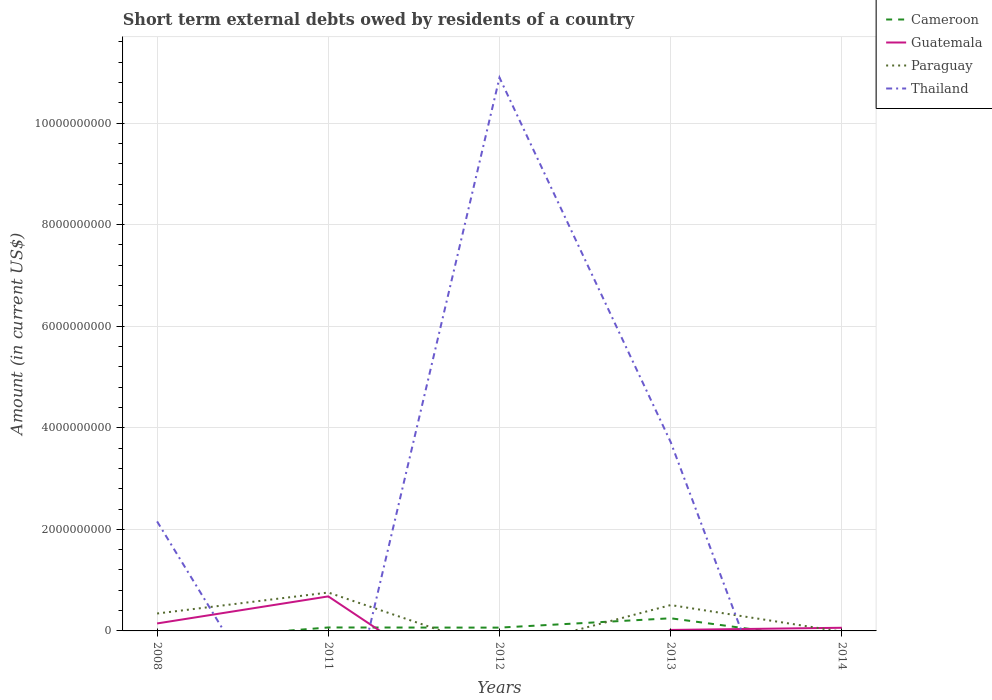Does the line corresponding to Guatemala intersect with the line corresponding to Cameroon?
Provide a succinct answer. Yes. Is the number of lines equal to the number of legend labels?
Give a very brief answer. No. What is the total amount of short-term external debts owed by residents in Cameroon in the graph?
Ensure brevity in your answer.  -1.84e+08. What is the difference between the highest and the second highest amount of short-term external debts owed by residents in Thailand?
Provide a short and direct response. 1.09e+1. What is the difference between the highest and the lowest amount of short-term external debts owed by residents in Paraguay?
Your response must be concise. 3. How many lines are there?
Offer a very short reply. 4. Are the values on the major ticks of Y-axis written in scientific E-notation?
Provide a short and direct response. No. Where does the legend appear in the graph?
Offer a very short reply. Top right. How many legend labels are there?
Provide a succinct answer. 4. What is the title of the graph?
Your answer should be very brief. Short term external debts owed by residents of a country. What is the label or title of the Y-axis?
Offer a terse response. Amount (in current US$). What is the Amount (in current US$) of Cameroon in 2008?
Ensure brevity in your answer.  0. What is the Amount (in current US$) in Guatemala in 2008?
Ensure brevity in your answer.  1.47e+08. What is the Amount (in current US$) of Paraguay in 2008?
Ensure brevity in your answer.  3.43e+08. What is the Amount (in current US$) of Thailand in 2008?
Offer a very short reply. 2.16e+09. What is the Amount (in current US$) in Cameroon in 2011?
Offer a very short reply. 6.80e+07. What is the Amount (in current US$) of Guatemala in 2011?
Ensure brevity in your answer.  6.80e+08. What is the Amount (in current US$) in Paraguay in 2011?
Provide a short and direct response. 7.56e+08. What is the Amount (in current US$) in Thailand in 2011?
Ensure brevity in your answer.  0. What is the Amount (in current US$) in Cameroon in 2012?
Your answer should be very brief. 6.50e+07. What is the Amount (in current US$) in Thailand in 2012?
Ensure brevity in your answer.  1.09e+1. What is the Amount (in current US$) of Cameroon in 2013?
Provide a short and direct response. 2.49e+08. What is the Amount (in current US$) of Guatemala in 2013?
Give a very brief answer. 1.94e+07. What is the Amount (in current US$) of Paraguay in 2013?
Make the answer very short. 5.09e+08. What is the Amount (in current US$) of Thailand in 2013?
Make the answer very short. 3.72e+09. What is the Amount (in current US$) of Guatemala in 2014?
Offer a very short reply. 6.20e+07. What is the Amount (in current US$) in Paraguay in 2014?
Keep it short and to the point. 0. Across all years, what is the maximum Amount (in current US$) of Cameroon?
Ensure brevity in your answer.  2.49e+08. Across all years, what is the maximum Amount (in current US$) of Guatemala?
Provide a succinct answer. 6.80e+08. Across all years, what is the maximum Amount (in current US$) in Paraguay?
Offer a very short reply. 7.56e+08. Across all years, what is the maximum Amount (in current US$) in Thailand?
Offer a very short reply. 1.09e+1. Across all years, what is the minimum Amount (in current US$) of Cameroon?
Make the answer very short. 0. What is the total Amount (in current US$) in Cameroon in the graph?
Offer a terse response. 3.82e+08. What is the total Amount (in current US$) in Guatemala in the graph?
Ensure brevity in your answer.  9.08e+08. What is the total Amount (in current US$) in Paraguay in the graph?
Your response must be concise. 1.61e+09. What is the total Amount (in current US$) in Thailand in the graph?
Provide a succinct answer. 1.68e+1. What is the difference between the Amount (in current US$) of Guatemala in 2008 and that in 2011?
Offer a very short reply. -5.33e+08. What is the difference between the Amount (in current US$) in Paraguay in 2008 and that in 2011?
Offer a terse response. -4.13e+08. What is the difference between the Amount (in current US$) in Thailand in 2008 and that in 2012?
Your answer should be very brief. -8.74e+09. What is the difference between the Amount (in current US$) of Guatemala in 2008 and that in 2013?
Your response must be concise. 1.28e+08. What is the difference between the Amount (in current US$) in Paraguay in 2008 and that in 2013?
Give a very brief answer. -1.66e+08. What is the difference between the Amount (in current US$) of Thailand in 2008 and that in 2013?
Offer a very short reply. -1.56e+09. What is the difference between the Amount (in current US$) of Guatemala in 2008 and that in 2014?
Offer a terse response. 8.50e+07. What is the difference between the Amount (in current US$) in Cameroon in 2011 and that in 2013?
Provide a succinct answer. -1.81e+08. What is the difference between the Amount (in current US$) in Guatemala in 2011 and that in 2013?
Provide a short and direct response. 6.61e+08. What is the difference between the Amount (in current US$) of Paraguay in 2011 and that in 2013?
Your answer should be compact. 2.47e+08. What is the difference between the Amount (in current US$) of Guatemala in 2011 and that in 2014?
Your answer should be compact. 6.18e+08. What is the difference between the Amount (in current US$) of Cameroon in 2012 and that in 2013?
Provide a succinct answer. -1.84e+08. What is the difference between the Amount (in current US$) in Thailand in 2012 and that in 2013?
Ensure brevity in your answer.  7.18e+09. What is the difference between the Amount (in current US$) in Guatemala in 2013 and that in 2014?
Your answer should be very brief. -4.26e+07. What is the difference between the Amount (in current US$) in Guatemala in 2008 and the Amount (in current US$) in Paraguay in 2011?
Give a very brief answer. -6.09e+08. What is the difference between the Amount (in current US$) of Guatemala in 2008 and the Amount (in current US$) of Thailand in 2012?
Provide a succinct answer. -1.07e+1. What is the difference between the Amount (in current US$) in Paraguay in 2008 and the Amount (in current US$) in Thailand in 2012?
Give a very brief answer. -1.06e+1. What is the difference between the Amount (in current US$) in Guatemala in 2008 and the Amount (in current US$) in Paraguay in 2013?
Make the answer very short. -3.62e+08. What is the difference between the Amount (in current US$) of Guatemala in 2008 and the Amount (in current US$) of Thailand in 2013?
Your answer should be very brief. -3.57e+09. What is the difference between the Amount (in current US$) in Paraguay in 2008 and the Amount (in current US$) in Thailand in 2013?
Ensure brevity in your answer.  -3.37e+09. What is the difference between the Amount (in current US$) of Cameroon in 2011 and the Amount (in current US$) of Thailand in 2012?
Provide a short and direct response. -1.08e+1. What is the difference between the Amount (in current US$) of Guatemala in 2011 and the Amount (in current US$) of Thailand in 2012?
Make the answer very short. -1.02e+1. What is the difference between the Amount (in current US$) of Paraguay in 2011 and the Amount (in current US$) of Thailand in 2012?
Keep it short and to the point. -1.01e+1. What is the difference between the Amount (in current US$) in Cameroon in 2011 and the Amount (in current US$) in Guatemala in 2013?
Ensure brevity in your answer.  4.86e+07. What is the difference between the Amount (in current US$) in Cameroon in 2011 and the Amount (in current US$) in Paraguay in 2013?
Give a very brief answer. -4.41e+08. What is the difference between the Amount (in current US$) of Cameroon in 2011 and the Amount (in current US$) of Thailand in 2013?
Your answer should be very brief. -3.65e+09. What is the difference between the Amount (in current US$) of Guatemala in 2011 and the Amount (in current US$) of Paraguay in 2013?
Make the answer very short. 1.71e+08. What is the difference between the Amount (in current US$) in Guatemala in 2011 and the Amount (in current US$) in Thailand in 2013?
Provide a succinct answer. -3.04e+09. What is the difference between the Amount (in current US$) of Paraguay in 2011 and the Amount (in current US$) of Thailand in 2013?
Ensure brevity in your answer.  -2.96e+09. What is the difference between the Amount (in current US$) of Cameroon in 2011 and the Amount (in current US$) of Guatemala in 2014?
Your answer should be compact. 6.00e+06. What is the difference between the Amount (in current US$) of Cameroon in 2012 and the Amount (in current US$) of Guatemala in 2013?
Your answer should be very brief. 4.56e+07. What is the difference between the Amount (in current US$) in Cameroon in 2012 and the Amount (in current US$) in Paraguay in 2013?
Your answer should be compact. -4.44e+08. What is the difference between the Amount (in current US$) in Cameroon in 2012 and the Amount (in current US$) in Thailand in 2013?
Your answer should be compact. -3.65e+09. What is the difference between the Amount (in current US$) in Cameroon in 2013 and the Amount (in current US$) in Guatemala in 2014?
Your response must be concise. 1.87e+08. What is the average Amount (in current US$) of Cameroon per year?
Ensure brevity in your answer.  7.64e+07. What is the average Amount (in current US$) in Guatemala per year?
Keep it short and to the point. 1.82e+08. What is the average Amount (in current US$) in Paraguay per year?
Your answer should be very brief. 3.22e+08. What is the average Amount (in current US$) in Thailand per year?
Offer a very short reply. 3.35e+09. In the year 2008, what is the difference between the Amount (in current US$) in Guatemala and Amount (in current US$) in Paraguay?
Provide a succinct answer. -1.96e+08. In the year 2008, what is the difference between the Amount (in current US$) of Guatemala and Amount (in current US$) of Thailand?
Your answer should be very brief. -2.01e+09. In the year 2008, what is the difference between the Amount (in current US$) of Paraguay and Amount (in current US$) of Thailand?
Offer a very short reply. -1.81e+09. In the year 2011, what is the difference between the Amount (in current US$) in Cameroon and Amount (in current US$) in Guatemala?
Make the answer very short. -6.12e+08. In the year 2011, what is the difference between the Amount (in current US$) of Cameroon and Amount (in current US$) of Paraguay?
Provide a succinct answer. -6.88e+08. In the year 2011, what is the difference between the Amount (in current US$) in Guatemala and Amount (in current US$) in Paraguay?
Give a very brief answer. -7.60e+07. In the year 2012, what is the difference between the Amount (in current US$) in Cameroon and Amount (in current US$) in Thailand?
Your answer should be compact. -1.08e+1. In the year 2013, what is the difference between the Amount (in current US$) of Cameroon and Amount (in current US$) of Guatemala?
Give a very brief answer. 2.30e+08. In the year 2013, what is the difference between the Amount (in current US$) of Cameroon and Amount (in current US$) of Paraguay?
Offer a very short reply. -2.60e+08. In the year 2013, what is the difference between the Amount (in current US$) in Cameroon and Amount (in current US$) in Thailand?
Keep it short and to the point. -3.47e+09. In the year 2013, what is the difference between the Amount (in current US$) in Guatemala and Amount (in current US$) in Paraguay?
Offer a very short reply. -4.90e+08. In the year 2013, what is the difference between the Amount (in current US$) of Guatemala and Amount (in current US$) of Thailand?
Offer a terse response. -3.70e+09. In the year 2013, what is the difference between the Amount (in current US$) in Paraguay and Amount (in current US$) in Thailand?
Keep it short and to the point. -3.21e+09. What is the ratio of the Amount (in current US$) of Guatemala in 2008 to that in 2011?
Your answer should be very brief. 0.22. What is the ratio of the Amount (in current US$) in Paraguay in 2008 to that in 2011?
Your answer should be very brief. 0.45. What is the ratio of the Amount (in current US$) in Thailand in 2008 to that in 2012?
Make the answer very short. 0.2. What is the ratio of the Amount (in current US$) in Guatemala in 2008 to that in 2013?
Your answer should be compact. 7.58. What is the ratio of the Amount (in current US$) of Paraguay in 2008 to that in 2013?
Provide a succinct answer. 0.67. What is the ratio of the Amount (in current US$) of Thailand in 2008 to that in 2013?
Ensure brevity in your answer.  0.58. What is the ratio of the Amount (in current US$) of Guatemala in 2008 to that in 2014?
Ensure brevity in your answer.  2.37. What is the ratio of the Amount (in current US$) of Cameroon in 2011 to that in 2012?
Make the answer very short. 1.05. What is the ratio of the Amount (in current US$) of Cameroon in 2011 to that in 2013?
Your answer should be very brief. 0.27. What is the ratio of the Amount (in current US$) in Guatemala in 2011 to that in 2013?
Provide a succinct answer. 35.05. What is the ratio of the Amount (in current US$) in Paraguay in 2011 to that in 2013?
Give a very brief answer. 1.49. What is the ratio of the Amount (in current US$) in Guatemala in 2011 to that in 2014?
Give a very brief answer. 10.97. What is the ratio of the Amount (in current US$) of Cameroon in 2012 to that in 2013?
Your response must be concise. 0.26. What is the ratio of the Amount (in current US$) of Thailand in 2012 to that in 2013?
Your answer should be very brief. 2.93. What is the ratio of the Amount (in current US$) of Guatemala in 2013 to that in 2014?
Provide a short and direct response. 0.31. What is the difference between the highest and the second highest Amount (in current US$) in Cameroon?
Your answer should be very brief. 1.81e+08. What is the difference between the highest and the second highest Amount (in current US$) of Guatemala?
Provide a succinct answer. 5.33e+08. What is the difference between the highest and the second highest Amount (in current US$) in Paraguay?
Your answer should be very brief. 2.47e+08. What is the difference between the highest and the second highest Amount (in current US$) in Thailand?
Your answer should be very brief. 7.18e+09. What is the difference between the highest and the lowest Amount (in current US$) in Cameroon?
Your response must be concise. 2.49e+08. What is the difference between the highest and the lowest Amount (in current US$) of Guatemala?
Give a very brief answer. 6.80e+08. What is the difference between the highest and the lowest Amount (in current US$) in Paraguay?
Offer a very short reply. 7.56e+08. What is the difference between the highest and the lowest Amount (in current US$) of Thailand?
Make the answer very short. 1.09e+1. 